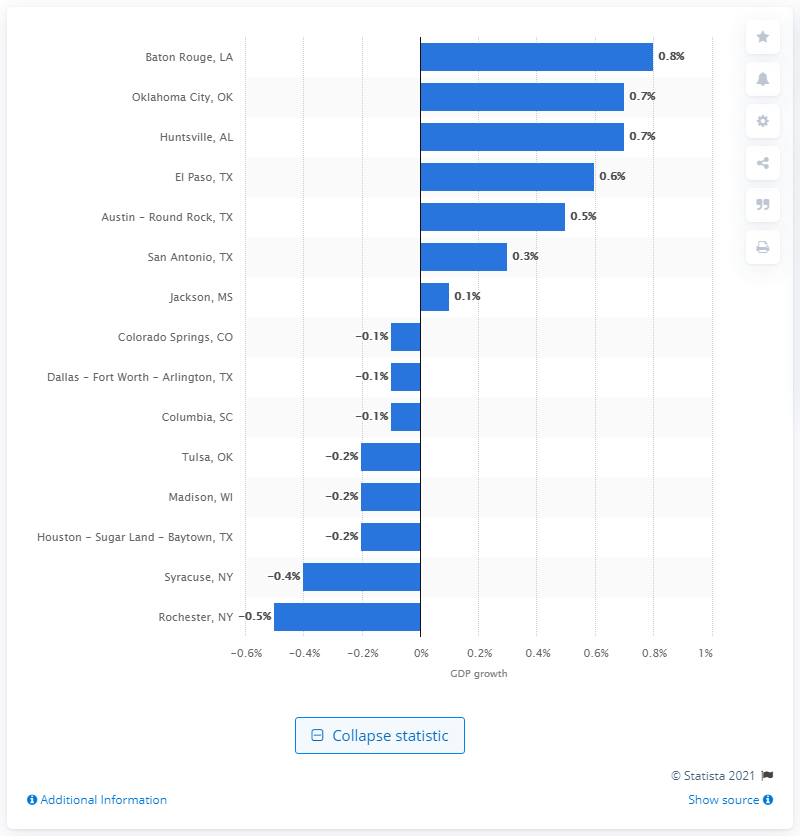Specify some key components in this picture. According to the real gross metro product growth rate in El Paso, Texas in 2009, the economic growth of the city was 0.6%. 